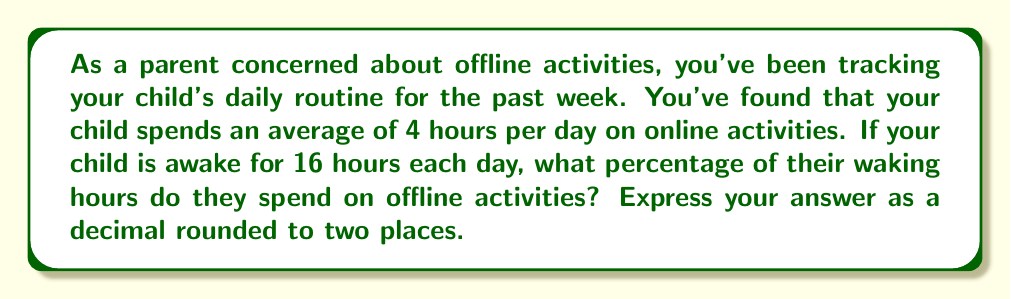Teach me how to tackle this problem. Let's approach this step-by-step:

1) First, we need to calculate the time spent on offline activities:
   $$\text{Offline time} = \text{Total waking hours} - \text{Online time}$$
   $$\text{Offline time} = 16 - 4 = 12 \text{ hours}$$

2) Now, we need to calculate the percentage of time spent on offline activities:
   $$\text{Percentage} = \frac{\text{Offline time}}{\text{Total waking hours}} \times 100\%$$

3) Plugging in our values:
   $$\text{Percentage} = \frac{12}{16} \times 100\%$$

4) Simplify the fraction:
   $$\text{Percentage} = \frac{3}{4} \times 100\% = 0.75 \times 100\% = 75\%$$

5) Convert to a decimal:
   $$75\% = 0.75$$

Therefore, the child spends 75% or 0.75 of their waking hours on offline activities.
Answer: 0.75 